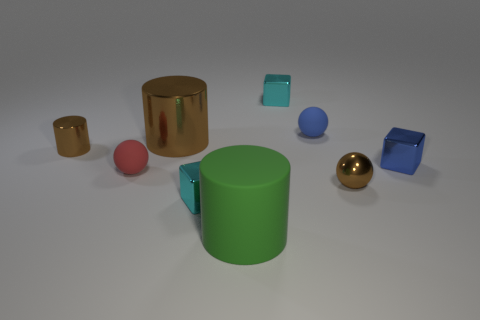Do the objects in the image seem real or computer-generated, and why? The objects in the image appear to be computer-generated. This can be deduced from the perfect geometric shapes, pristine surfaces without imperfections, and the uniform lighting. Natural imperfections and variances in lighting are typically present in photographs of real-world objects. 